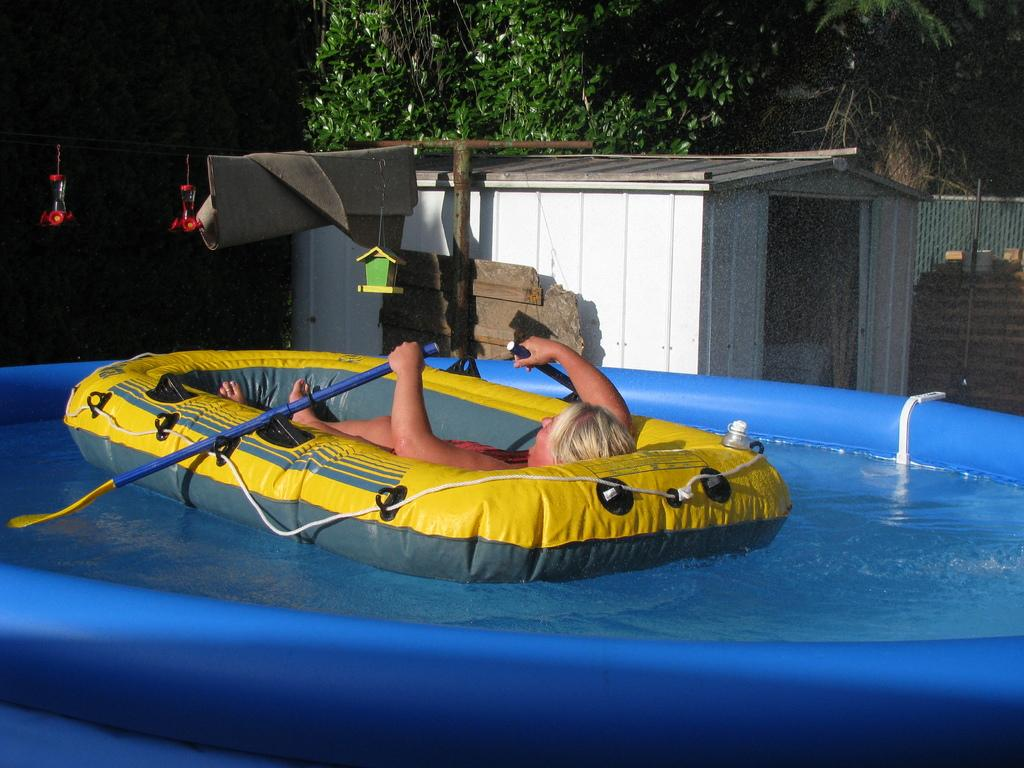What is the person in the image using to float in the water? The person is in a swimming bed in the pool. Can you describe the surroundings of the pool? There is a booth, a fence, and trees visible in the image. What is hanging from a rope in the image? There are objects hanging from a rope. What is the color and state of the banner in the image? The banner is white and folded. Are there any cherries growing on the trees in the image? There is no mention of cherries or trees bearing fruit in the image. Can you see a train passing by in the image? There is no train visible in the image. 